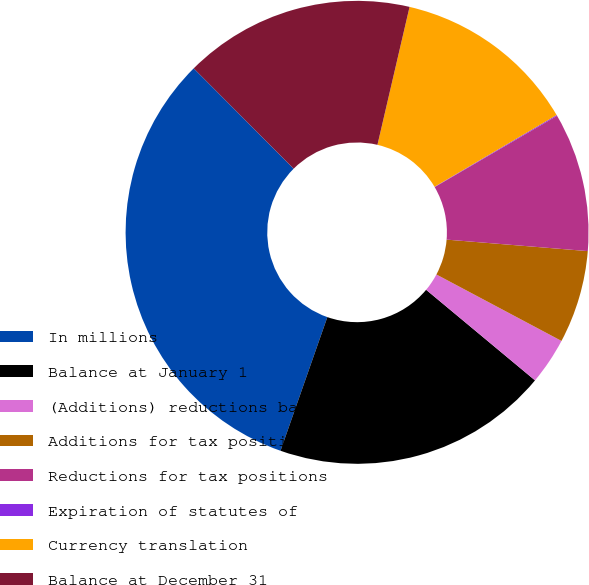Convert chart to OTSL. <chart><loc_0><loc_0><loc_500><loc_500><pie_chart><fcel>In millions<fcel>Balance at January 1<fcel>(Additions) reductions based<fcel>Additions for tax positions of<fcel>Reductions for tax positions<fcel>Expiration of statutes of<fcel>Currency translation<fcel>Balance at December 31<nl><fcel>32.16%<fcel>19.32%<fcel>3.27%<fcel>6.48%<fcel>9.69%<fcel>0.06%<fcel>12.9%<fcel>16.11%<nl></chart> 